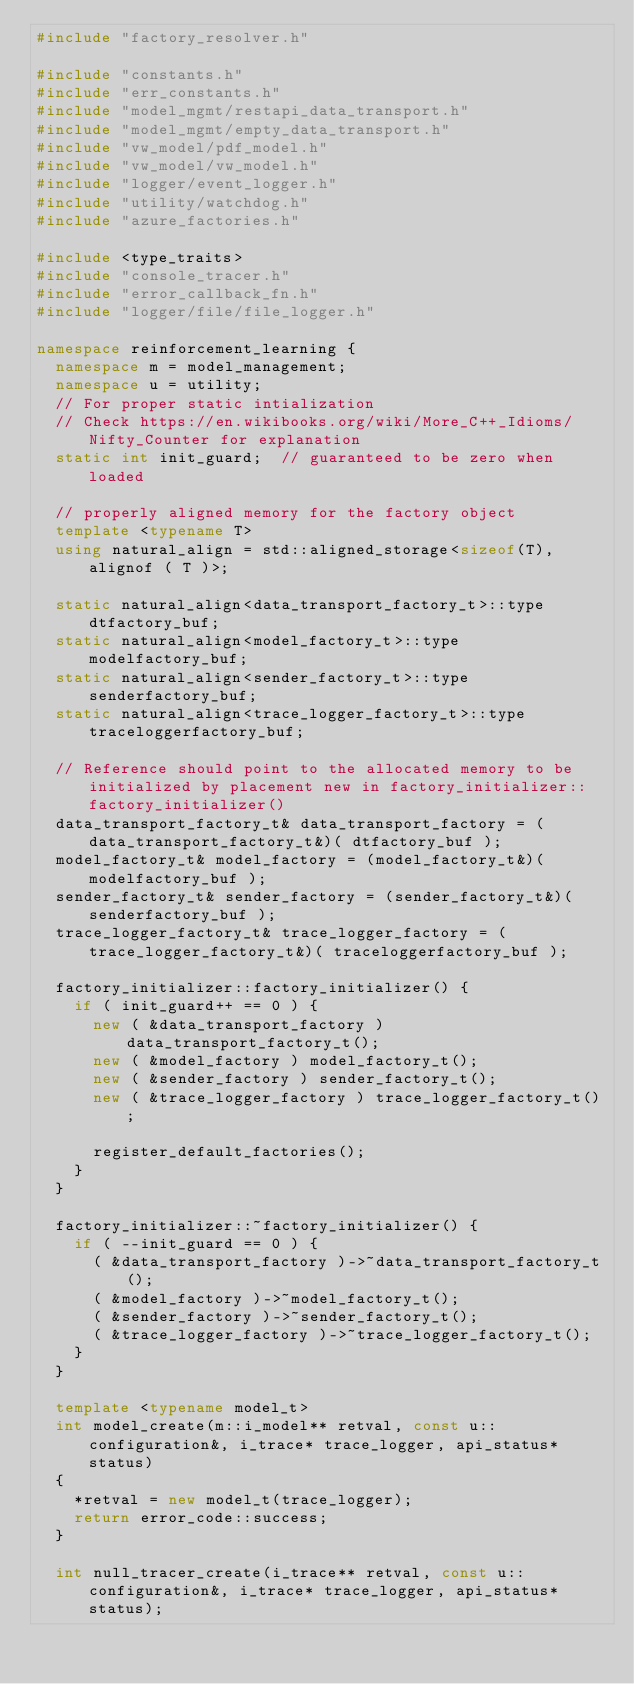<code> <loc_0><loc_0><loc_500><loc_500><_C++_>#include "factory_resolver.h"

#include "constants.h"
#include "err_constants.h"
#include "model_mgmt/restapi_data_transport.h"
#include "model_mgmt/empty_data_transport.h"
#include "vw_model/pdf_model.h"
#include "vw_model/vw_model.h"
#include "logger/event_logger.h"
#include "utility/watchdog.h"
#include "azure_factories.h"

#include <type_traits>
#include "console_tracer.h"
#include "error_callback_fn.h"
#include "logger/file/file_logger.h"

namespace reinforcement_learning {
  namespace m = model_management;
  namespace u = utility;
  // For proper static intialization
  // Check https://en.wikibooks.org/wiki/More_C++_Idioms/Nifty_Counter for explanation
  static int init_guard;  // guaranteed to be zero when loaded

  // properly aligned memory for the factory object
  template <typename T>
  using natural_align = std::aligned_storage<sizeof(T), alignof ( T )>;

  static natural_align<data_transport_factory_t>::type dtfactory_buf;
  static natural_align<model_factory_t>::type modelfactory_buf;
  static natural_align<sender_factory_t>::type senderfactory_buf;
  static natural_align<trace_logger_factory_t>::type traceloggerfactory_buf;

  // Reference should point to the allocated memory to be initialized by placement new in factory_initializer::factory_initializer()
  data_transport_factory_t& data_transport_factory = (data_transport_factory_t&)( dtfactory_buf );
  model_factory_t& model_factory = (model_factory_t&)( modelfactory_buf );
  sender_factory_t& sender_factory = (sender_factory_t&)( senderfactory_buf );
  trace_logger_factory_t& trace_logger_factory = (trace_logger_factory_t&)( traceloggerfactory_buf );

  factory_initializer::factory_initializer() {
    if ( init_guard++ == 0 ) {
      new ( &data_transport_factory ) data_transport_factory_t();
      new ( &model_factory ) model_factory_t();
      new ( &sender_factory ) sender_factory_t();
      new ( &trace_logger_factory ) trace_logger_factory_t();

      register_default_factories();
    }
  }

  factory_initializer::~factory_initializer() {
    if ( --init_guard == 0 ) {
      ( &data_transport_factory )->~data_transport_factory_t();
      ( &model_factory )->~model_factory_t();
      ( &sender_factory )->~sender_factory_t();
      ( &trace_logger_factory )->~trace_logger_factory_t();
    }
  }

  template <typename model_t>
  int model_create(m::i_model** retval, const u::configuration&, i_trace* trace_logger, api_status* status)
  {
    *retval = new model_t(trace_logger);
    return error_code::success;
  }

  int null_tracer_create(i_trace** retval, const u::configuration&, i_trace* trace_logger, api_status* status);</code> 